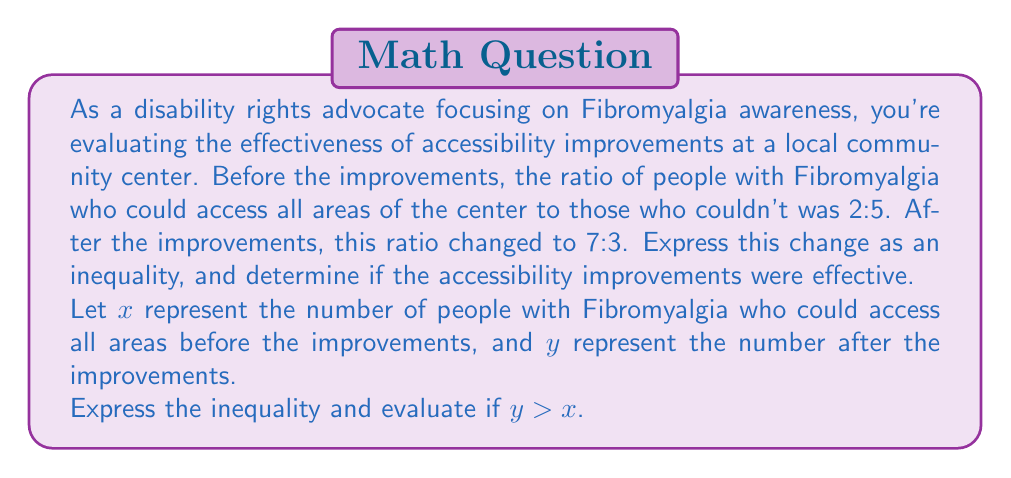Can you solve this math problem? To solve this problem, we'll follow these steps:

1) Express the ratios as fractions:
   Before improvements: $\frac{x}{x+5x/2} = \frac{2}{7}$
   After improvements: $\frac{y}{y+3y/7} = \frac{7}{10}$

2) Simplify the fractions:
   $\frac{x}{7x/2} = \frac{2}{7}$
   $\frac{y}{10y/7} = \frac{7}{10}$

3) Cross multiply to solve for x and y:
   For x: $2 \cdot \frac{7x}{2} = 7x$
   For y: $7 \cdot \frac{10y}{7} = 10y$

4) The total number of people with Fibromyalgia remains constant. Let's call this total T.
   Before: $T = x + 5x/2 = 7x/2$
   After: $T = y + 3y/7 = 10y/7$

5) Set these equal:
   $\frac{7x}{2} = \frac{10y}{7}$

6) Cross multiply:
   $49x = 20y$

7) Divide both sides by 20:
   $\frac{49x}{20} = y$

8) To determine if $y > x$, we need to evaluate if $\frac{49}{20} > 1$:
   $\frac{49}{20} = 2.45 > 1$

Therefore, $y > x$, which means the number of people who can access all areas after the improvements is greater than before.
Answer: The inequality expressing the change is:

$y > \frac{49x}{20}$

Since $\frac{49}{20} > 1$, we can conclude that $y > x$. This means the accessibility improvements were effective, as more people with Fibromyalgia can now access all areas of the community center compared to before the improvements. 